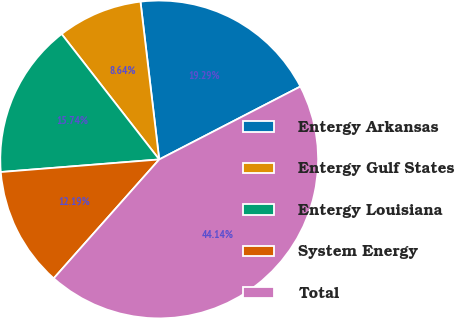Convert chart. <chart><loc_0><loc_0><loc_500><loc_500><pie_chart><fcel>Entergy Arkansas<fcel>Entergy Gulf States<fcel>Entergy Louisiana<fcel>System Energy<fcel>Total<nl><fcel>19.29%<fcel>8.64%<fcel>15.74%<fcel>12.19%<fcel>44.14%<nl></chart> 